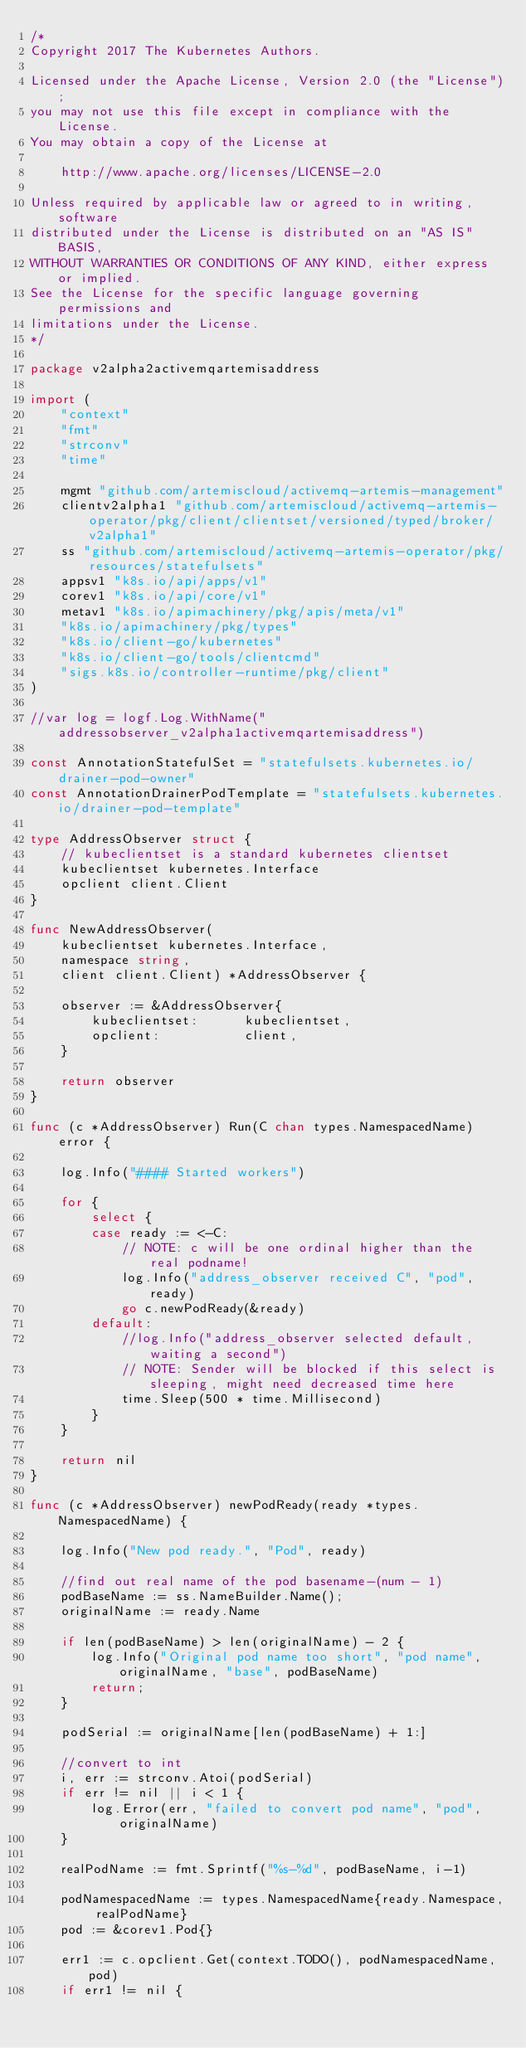Convert code to text. <code><loc_0><loc_0><loc_500><loc_500><_Go_>/*
Copyright 2017 The Kubernetes Authors.

Licensed under the Apache License, Version 2.0 (the "License");
you may not use this file except in compliance with the License.
You may obtain a copy of the License at

    http://www.apache.org/licenses/LICENSE-2.0

Unless required by applicable law or agreed to in writing, software
distributed under the License is distributed on an "AS IS" BASIS,
WITHOUT WARRANTIES OR CONDITIONS OF ANY KIND, either express or implied.
See the License for the specific language governing permissions and
limitations under the License.
*/

package v2alpha2activemqartemisaddress

import (
	"context"
	"fmt"
	"strconv"
	"time"

	mgmt "github.com/artemiscloud/activemq-artemis-management"
	clientv2alpha1 "github.com/artemiscloud/activemq-artemis-operator/pkg/client/clientset/versioned/typed/broker/v2alpha1"
	ss "github.com/artemiscloud/activemq-artemis-operator/pkg/resources/statefulsets"
	appsv1 "k8s.io/api/apps/v1"
	corev1 "k8s.io/api/core/v1"
	metav1 "k8s.io/apimachinery/pkg/apis/meta/v1"
	"k8s.io/apimachinery/pkg/types"
	"k8s.io/client-go/kubernetes"
	"k8s.io/client-go/tools/clientcmd"
	"sigs.k8s.io/controller-runtime/pkg/client"
)

//var log = logf.Log.WithName("addressobserver_v2alpha1activemqartemisaddress")

const AnnotationStatefulSet = "statefulsets.kubernetes.io/drainer-pod-owner"
const AnnotationDrainerPodTemplate = "statefulsets.kubernetes.io/drainer-pod-template"

type AddressObserver struct {
	// kubeclientset is a standard kubernetes clientset
	kubeclientset kubernetes.Interface
	opclient client.Client
}

func NewAddressObserver(
	kubeclientset kubernetes.Interface,
	namespace string,
	client client.Client) *AddressObserver {

	observer := &AddressObserver{
		kubeclientset:      kubeclientset,
		opclient:			client,
	}

	return observer
}

func (c *AddressObserver) Run(C chan types.NamespacedName) error {

	log.Info("#### Started workers")

	for {
		select {
		case ready := <-C:
			// NOTE: c will be one ordinal higher than the real podname!
			log.Info("address_observer received C", "pod", ready)
			go c.newPodReady(&ready)
		default:
			//log.Info("address_observer selected default, waiting a second")
			// NOTE: Sender will be blocked if this select is sleeping, might need decreased time here
			time.Sleep(500 * time.Millisecond)
		}
	}

	return nil
}

func (c *AddressObserver) newPodReady(ready *types.NamespacedName) {

	log.Info("New pod ready.", "Pod", ready)

    //find out real name of the pod basename-(num - 1)
	podBaseName := ss.NameBuilder.Name();
	originalName := ready.Name
	
	if len(podBaseName) > len(originalName) - 2 {
		log.Info("Original pod name too short", "pod name", originalName, "base", podBaseName)
		return;
	}

	podSerial := originalName[len(podBaseName) + 1:]

	//convert to int
	i, err := strconv.Atoi(podSerial)
	if err != nil || i < 1 {
		log.Error(err, "failed to convert pod name", "pod", originalName)
	}

    realPodName := fmt.Sprintf("%s-%d", podBaseName, i-1)
    
    podNamespacedName := types.NamespacedName{ready.Namespace, realPodName}
    pod := &corev1.Pod{}

    err1 := c.opclient.Get(context.TODO(), podNamespacedName, pod)
	if err1 != nil {</code> 